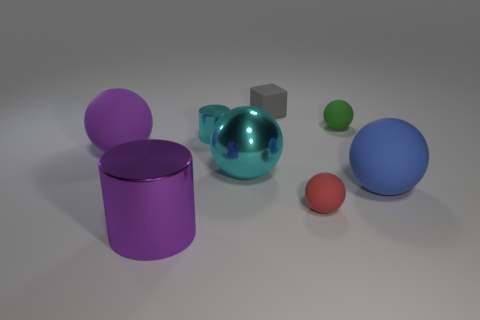What is the cylinder that is right of the large purple cylinder made of?
Offer a terse response. Metal. Is the number of big shiny objects less than the number of big spheres?
Your response must be concise. Yes. What shape is the metallic object that is both in front of the cyan cylinder and on the right side of the purple metal cylinder?
Give a very brief answer. Sphere. How many purple metallic cylinders are there?
Your response must be concise. 1. There is a small thing that is right of the tiny ball in front of the large rubber ball that is on the right side of the cube; what is it made of?
Your response must be concise. Rubber. There is a shiny cylinder that is behind the purple cylinder; how many balls are right of it?
Keep it short and to the point. 4. What is the color of the metallic thing that is the same shape as the red rubber thing?
Give a very brief answer. Cyan. Are the blue thing and the green object made of the same material?
Provide a succinct answer. Yes. What number of cylinders are either large cyan rubber things or purple matte objects?
Your answer should be compact. 0. There is a cylinder that is in front of the cylinder that is behind the large ball that is to the right of the tiny green object; what size is it?
Offer a terse response. Large. 